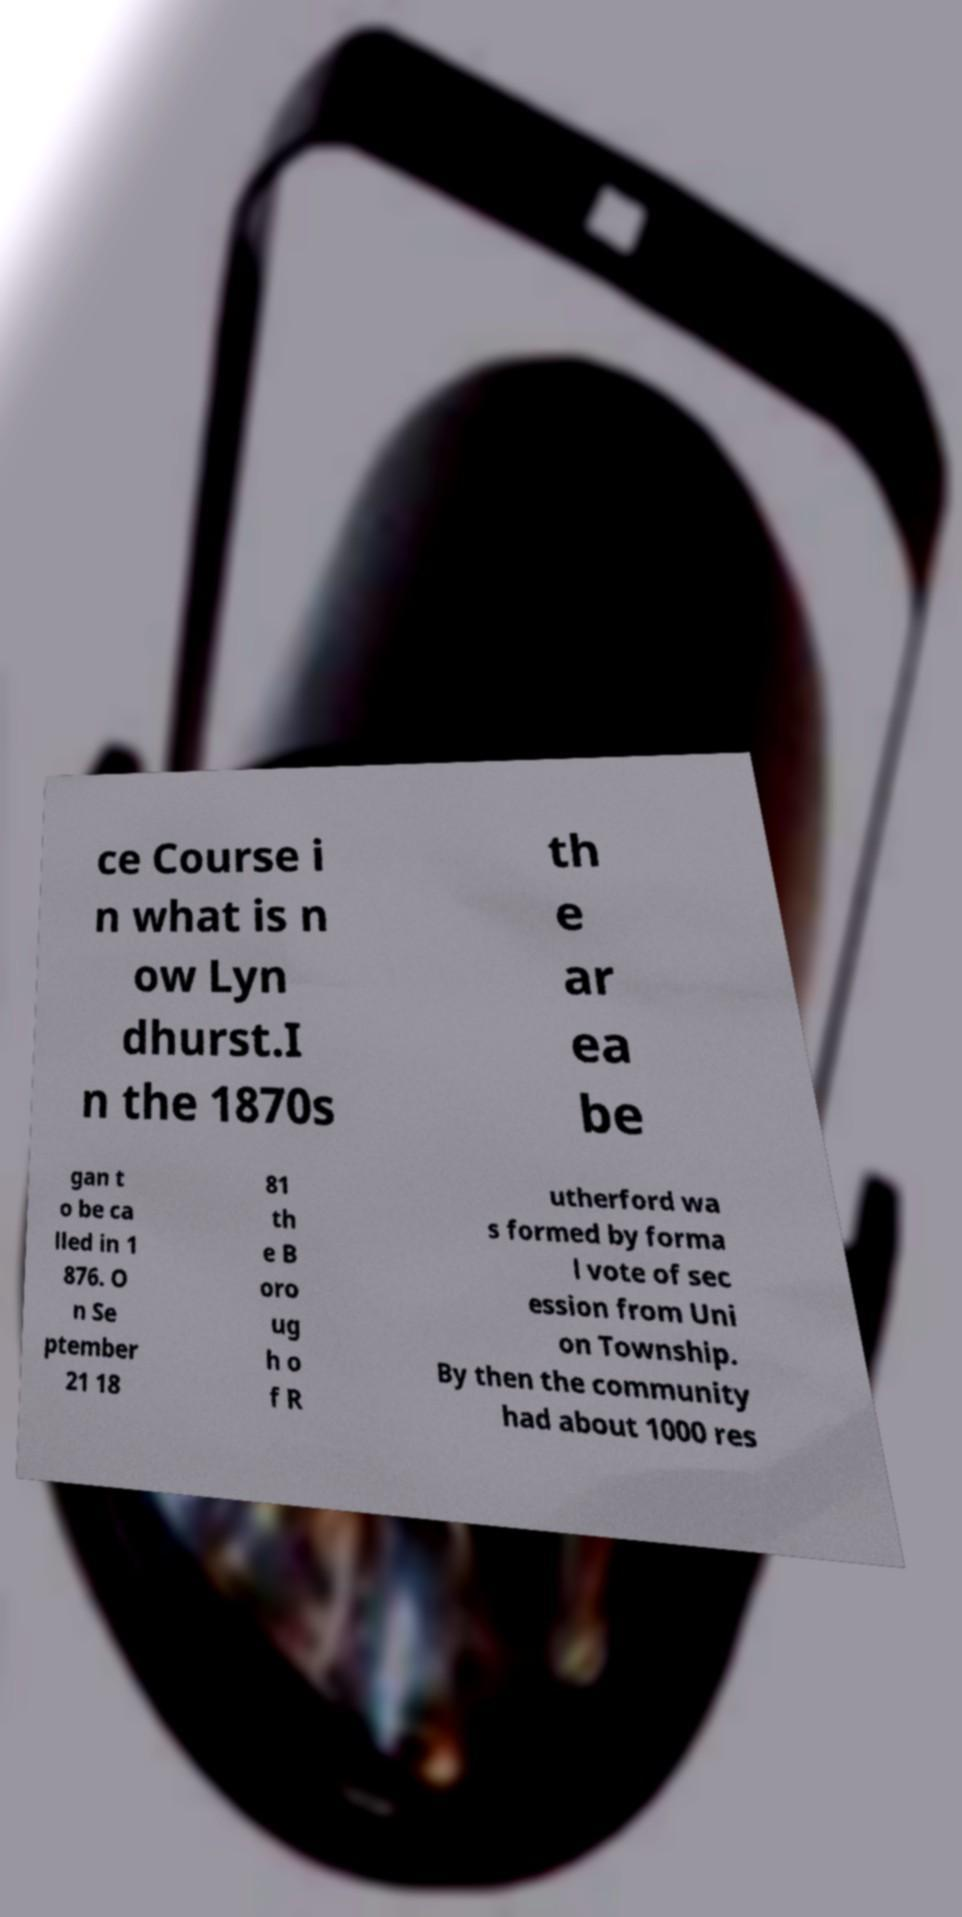What messages or text are displayed in this image? I need them in a readable, typed format. ce Course i n what is n ow Lyn dhurst.I n the 1870s th e ar ea be gan t o be ca lled in 1 876. O n Se ptember 21 18 81 th e B oro ug h o f R utherford wa s formed by forma l vote of sec ession from Uni on Township. By then the community had about 1000 res 